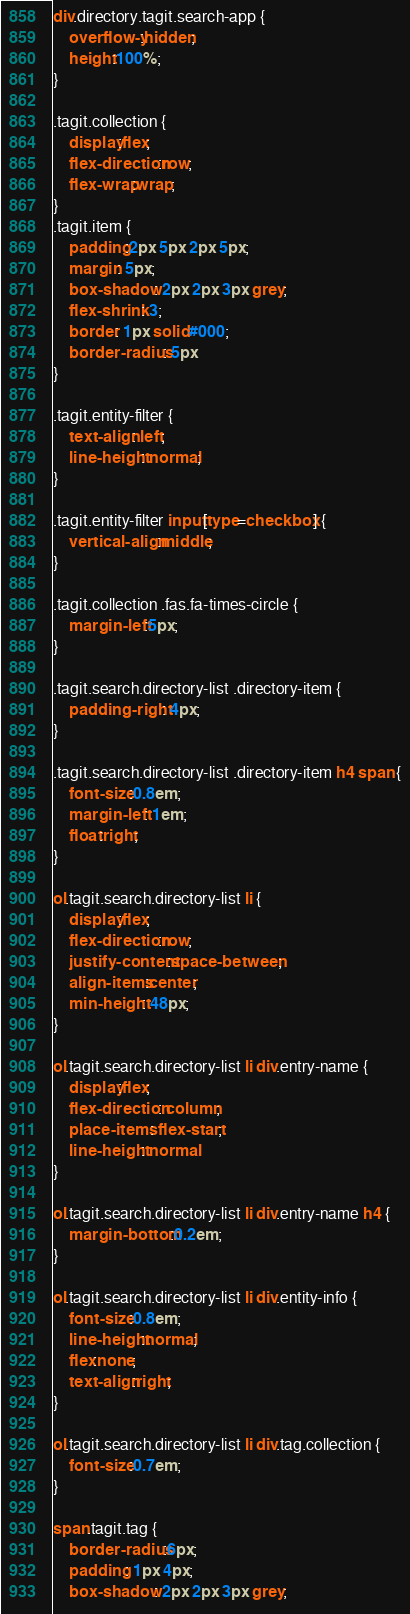Convert code to text. <code><loc_0><loc_0><loc_500><loc_500><_CSS_>div.directory.tagit.search-app {
    overflow-y:hidden;
    height:100%;
}

.tagit.collection {
    display:flex;
    flex-direction:row;
    flex-wrap:wrap;
}
.tagit.item {
    padding:2px 5px 2px 5px;
    margin: 5px;
    box-shadow: 2px 2px 3px grey;
    flex-shrink: 3;
    border: 1px solid #000;
    border-radius: 5px
}

.tagit.entity-filter {
    text-align: left;
    line-height: normal;
}

.tagit.entity-filter input[type=checkbox] {
    vertical-align:middle;
}

.tagit.collection .fas.fa-times-circle {
    margin-left:5px;
}

.tagit.search.directory-list .directory-item {
    padding-right: 4px;
}

.tagit.search.directory-list .directory-item h4 span {
    font-size:0.8em;
    margin-left: 1em;
    float:right;
}

ol.tagit.search.directory-list li {
    display:flex;
    flex-direction:row;
    justify-content:space-between;
    align-items:center;
    min-height: 48px;
}

ol.tagit.search.directory-list li div.entry-name {
    display:flex;
    flex-direction: column;
    place-items: flex-start;
    line-height: normal
}

ol.tagit.search.directory-list li div.entry-name h4 {
    margin-bottom:0.2em;
}

ol.tagit.search.directory-list li div.entity-info {
    font-size:0.8em;
    line-height:normal;
    flex:none;
    text-align:right;
}

ol.tagit.search.directory-list li div.tag.collection {
    font-size:0.7em;
}

span.tagit.tag {
    border-radius:6px;
    padding: 1px 4px;
    box-shadow: 2px 2px 3px grey;</code> 